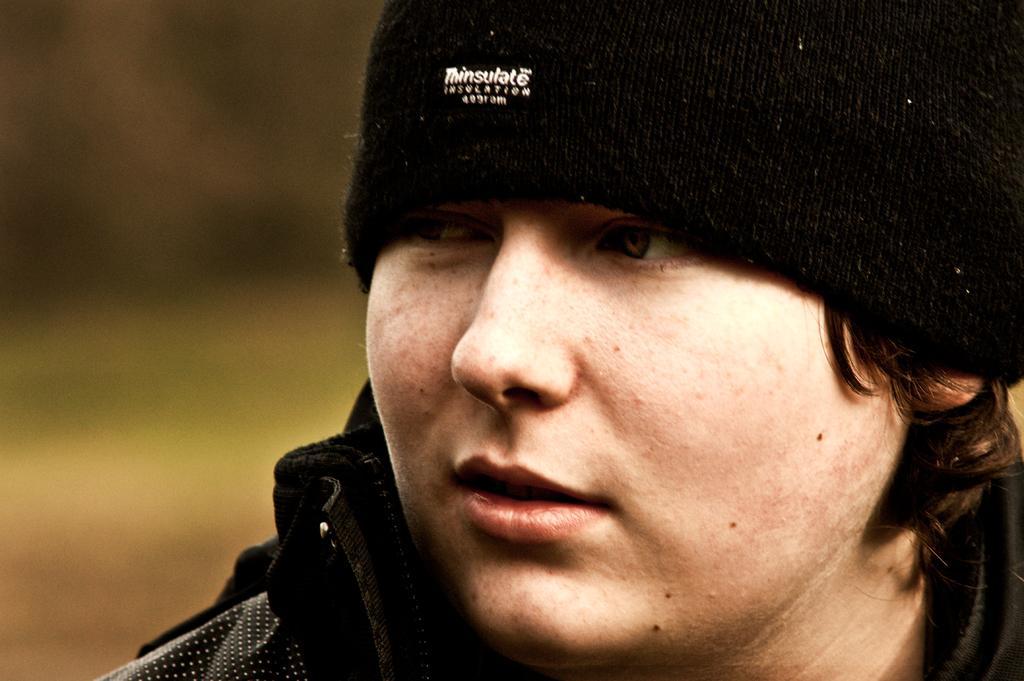How would you summarize this image in a sentence or two? There is a person wearing a black cap and something is written on the cap. In the background it is blurred. 